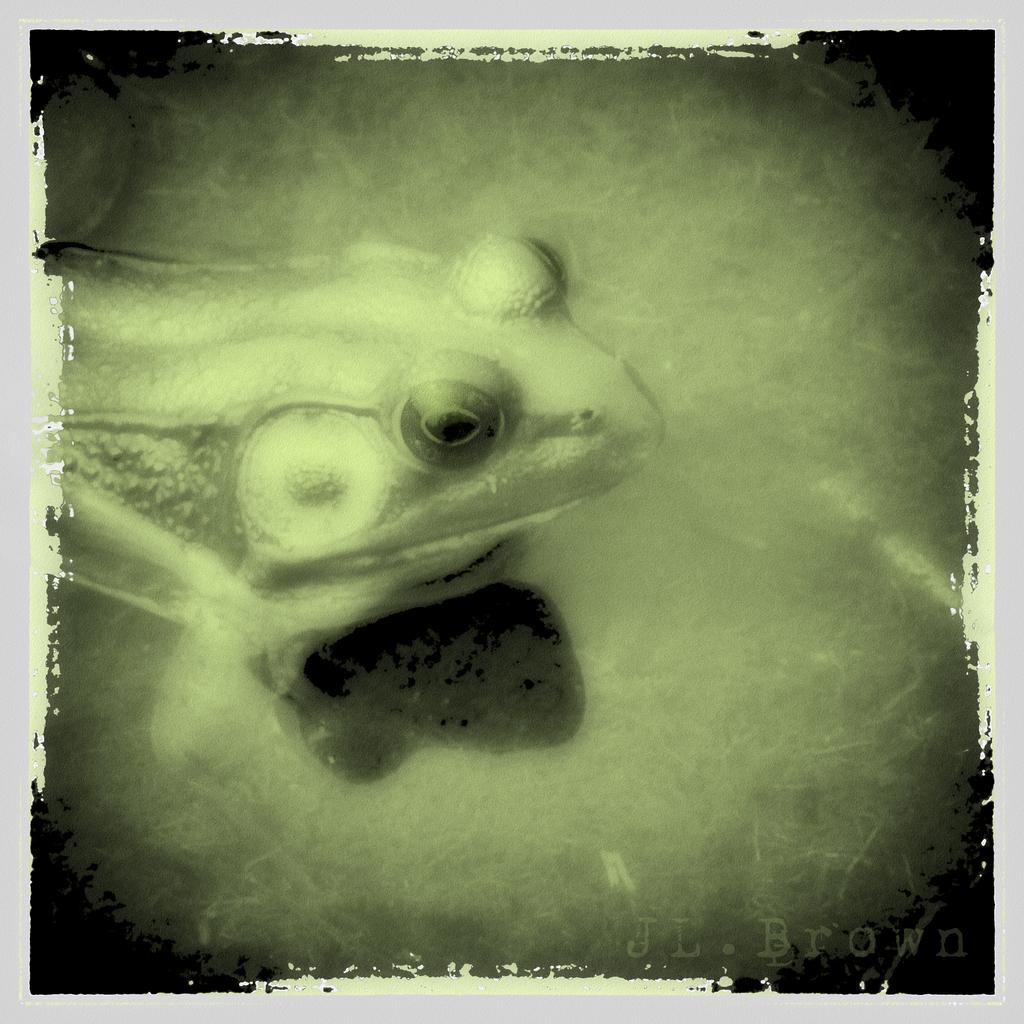What type of animal is in the image? There is a frog in the image. Where is the frog located? The frog is on an object. Is there any text present in the image? Yes, there is text written in the right bottom corner of the image. How does the frog use its chin to ride the bike in the image? There is no bike present in the image, and frogs do not have chins. 